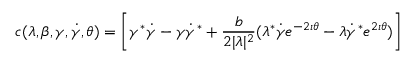Convert formula to latex. <formula><loc_0><loc_0><loc_500><loc_500>c ( \lambda , \beta , \gamma , \dot { \gamma } , \theta ) = \left [ \gamma ^ { * } \dot { \gamma } - \gamma \dot { \gamma } ^ { * } + \frac { b } { 2 | \lambda | ^ { 2 } } ( \lambda ^ { * } \dot { \gamma } e ^ { - 2 \imath \theta } - \lambda \dot { \gamma } ^ { * } e ^ { 2 \imath \theta } ) \right ]</formula> 